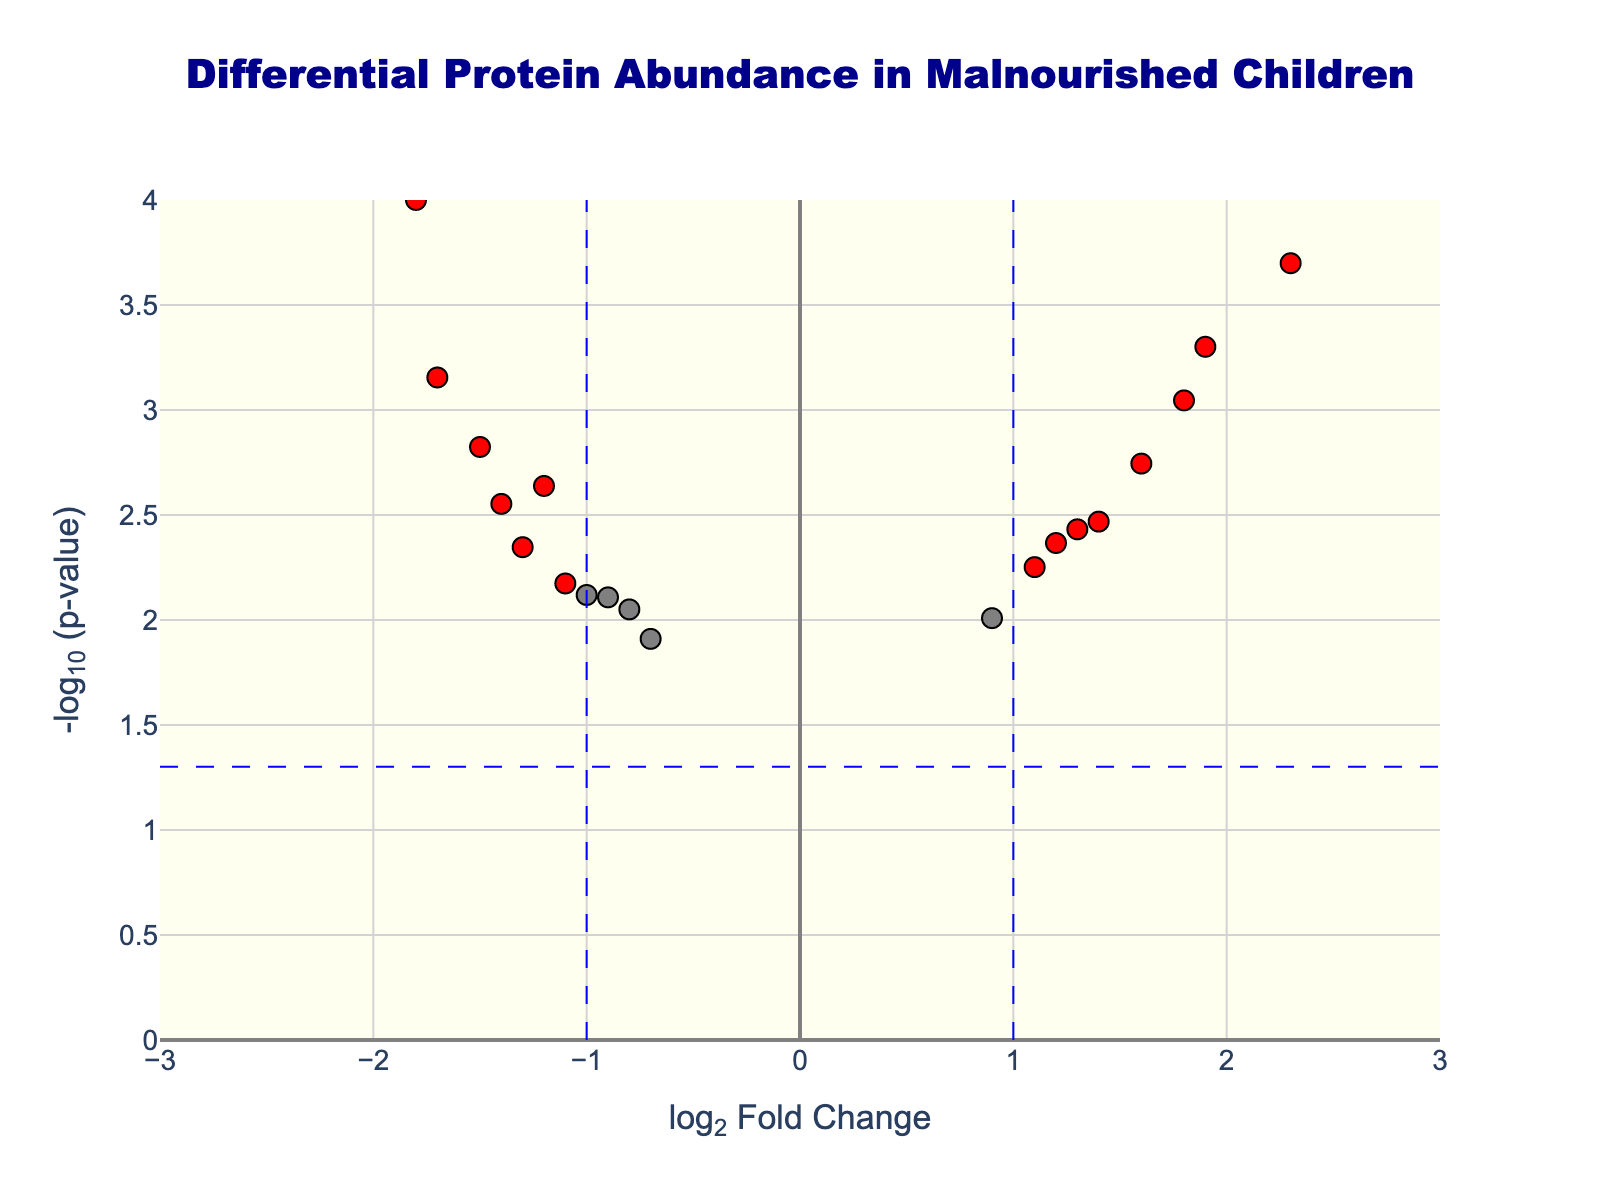How many proteins have been identified as significantly different in abundance between malnourished and well-nourished children? To determine this, look for red dots on the plot because they indicate significant changes. According to the plot, there are several red dots representing differentially abundant proteins.
Answer: 12 Which protein shows the highest fold change in malnourished children compared to well-nourished children? By inspecting the x-axis values (log2FoldChange), find the data point that is furthest to the right among the red dots. The highest log2FoldChange is associated with "C-reactive protein."
Answer: C-reactive protein What is the log2FoldChange and p-value for Transthyretin? Hover over the data point labeled as Transthyretin to get its log2FoldChange and p-value. The log2FoldChange is -1.8, and the p-value is 0.0001.
Answer: -1.8 and 0.0001 How many proteins are more abundant in malnourished children (positive log2FoldChange) and have a p-value less than 0.05? Check the red dots on the right side of the plot (positive log2FoldChange). Count these red dots. There are 7 proteins that meet this criterion.
Answer: 7 Which protein has the lowest p-value while showing increased abundance in malnourished children? Inspect the y-axis (negative log10 p-value) for the highest point among the red dots on the right side of the plot (positive log2FoldChange). The lowest p-value (highest point) corresponds to "C-reactive protein."
Answer: C-reactive protein Is Albumin more or less abundant in malnourished children compared to well-nourished children? Locate Albumin on the plot by its label. Its log2FoldChange is -1.2, indicating it is less abundant in malnourished children.
Answer: Less abundant Which protein has the smallest change in abundance yet is still statistically significant? Examine the red dots (significant changes) closer to the y-axis (log2FoldChange near 0). "Complement C3" has a log2FoldChange of 0.9, the smallest significant change.
Answer: Complement C3 Identify the protein with the highest log2FoldChange reduction and its corresponding p-value. Look for the furthest left red dot regarding log2FoldChange on the plot. "Transthyretin" has the highest reduction at -1.8, with a p-value of 0.0001.
Answer: Transthyretin, 0.0001 What are the log2FoldChange values of the proteins with p-values below 0.005? Examine the log2FoldChange values of the red dots above the threshold line (-log10(0.005)). Proteins with significant p-values (<0.005) include Albumin (-1.2), Transthyretin (-1.8), Retinol-binding protein (-1.5), C-reactive protein (2.3), Interleukin-6 (1.8), Tumor necrosis factor-alpha (1.6), Leptin (-1.7), Ghrelin (1.4), Haptoglobin (1.2), and Serum amyloid A (1.9).
Answer: -1.2, -1.8, -1.5, 2.3, 1.8, 1.6, -1.7, 1.4, 1.2, and 1.9 